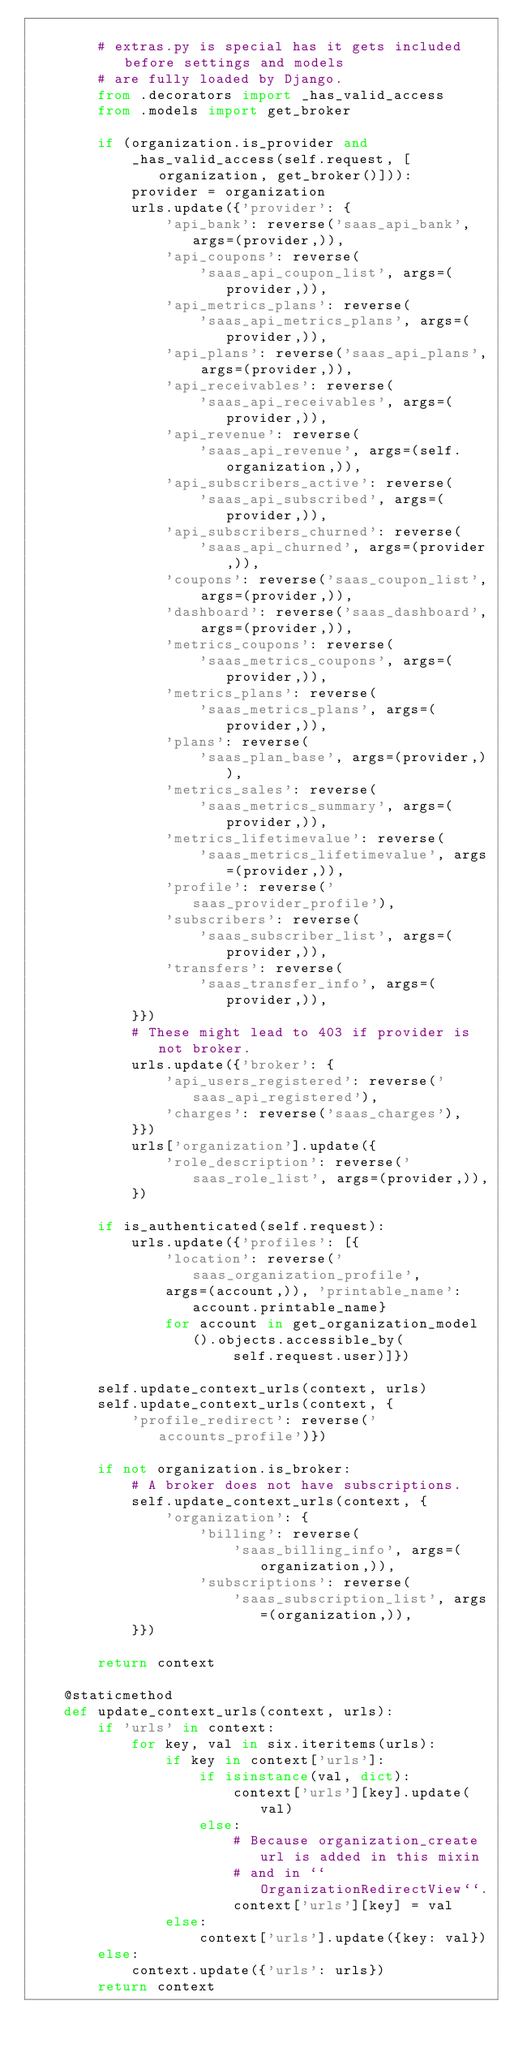<code> <loc_0><loc_0><loc_500><loc_500><_Python_>
        # extras.py is special has it gets included before settings and models
        # are fully loaded by Django.
        from .decorators import _has_valid_access
        from .models import get_broker

        if (organization.is_provider and
            _has_valid_access(self.request, [organization, get_broker()])):
            provider = organization
            urls.update({'provider': {
                'api_bank': reverse('saas_api_bank', args=(provider,)),
                'api_coupons': reverse(
                    'saas_api_coupon_list', args=(provider,)),
                'api_metrics_plans': reverse(
                    'saas_api_metrics_plans', args=(provider,)),
                'api_plans': reverse('saas_api_plans', args=(provider,)),
                'api_receivables': reverse(
                    'saas_api_receivables', args=(provider,)),
                'api_revenue': reverse(
                    'saas_api_revenue', args=(self.organization,)),
                'api_subscribers_active': reverse(
                    'saas_api_subscribed', args=(provider,)),
                'api_subscribers_churned': reverse(
                    'saas_api_churned', args=(provider,)),
                'coupons': reverse('saas_coupon_list', args=(provider,)),
                'dashboard': reverse('saas_dashboard', args=(provider,)),
                'metrics_coupons': reverse(
                    'saas_metrics_coupons', args=(provider,)),
                'metrics_plans': reverse(
                    'saas_metrics_plans', args=(provider,)),
                'plans': reverse(
                    'saas_plan_base', args=(provider,)),
                'metrics_sales': reverse(
                    'saas_metrics_summary', args=(provider,)),
                'metrics_lifetimevalue': reverse(
                    'saas_metrics_lifetimevalue', args=(provider,)),
                'profile': reverse('saas_provider_profile'),
                'subscribers': reverse(
                    'saas_subscriber_list', args=(provider,)),
                'transfers': reverse(
                    'saas_transfer_info', args=(provider,)),
            }})
            # These might lead to 403 if provider is not broker.
            urls.update({'broker': {
                'api_users_registered': reverse('saas_api_registered'),
                'charges': reverse('saas_charges'),
            }})
            urls['organization'].update({
                'role_description': reverse('saas_role_list', args=(provider,)),
            })

        if is_authenticated(self.request):
            urls.update({'profiles': [{
                'location': reverse('saas_organization_profile',
                args=(account,)), 'printable_name': account.printable_name}
                for account in get_organization_model().objects.accessible_by(
                        self.request.user)]})

        self.update_context_urls(context, urls)
        self.update_context_urls(context, {
            'profile_redirect': reverse('accounts_profile')})

        if not organization.is_broker:
            # A broker does not have subscriptions.
            self.update_context_urls(context, {
                'organization': {
                    'billing': reverse(
                        'saas_billing_info', args=(organization,)),
                    'subscriptions': reverse(
                        'saas_subscription_list', args=(organization,)),
            }})

        return context

    @staticmethod
    def update_context_urls(context, urls):
        if 'urls' in context:
            for key, val in six.iteritems(urls):
                if key in context['urls']:
                    if isinstance(val, dict):
                        context['urls'][key].update(val)
                    else:
                        # Because organization_create url is added in this mixin
                        # and in ``OrganizationRedirectView``.
                        context['urls'][key] = val
                else:
                    context['urls'].update({key: val})
        else:
            context.update({'urls': urls})
        return context
</code> 